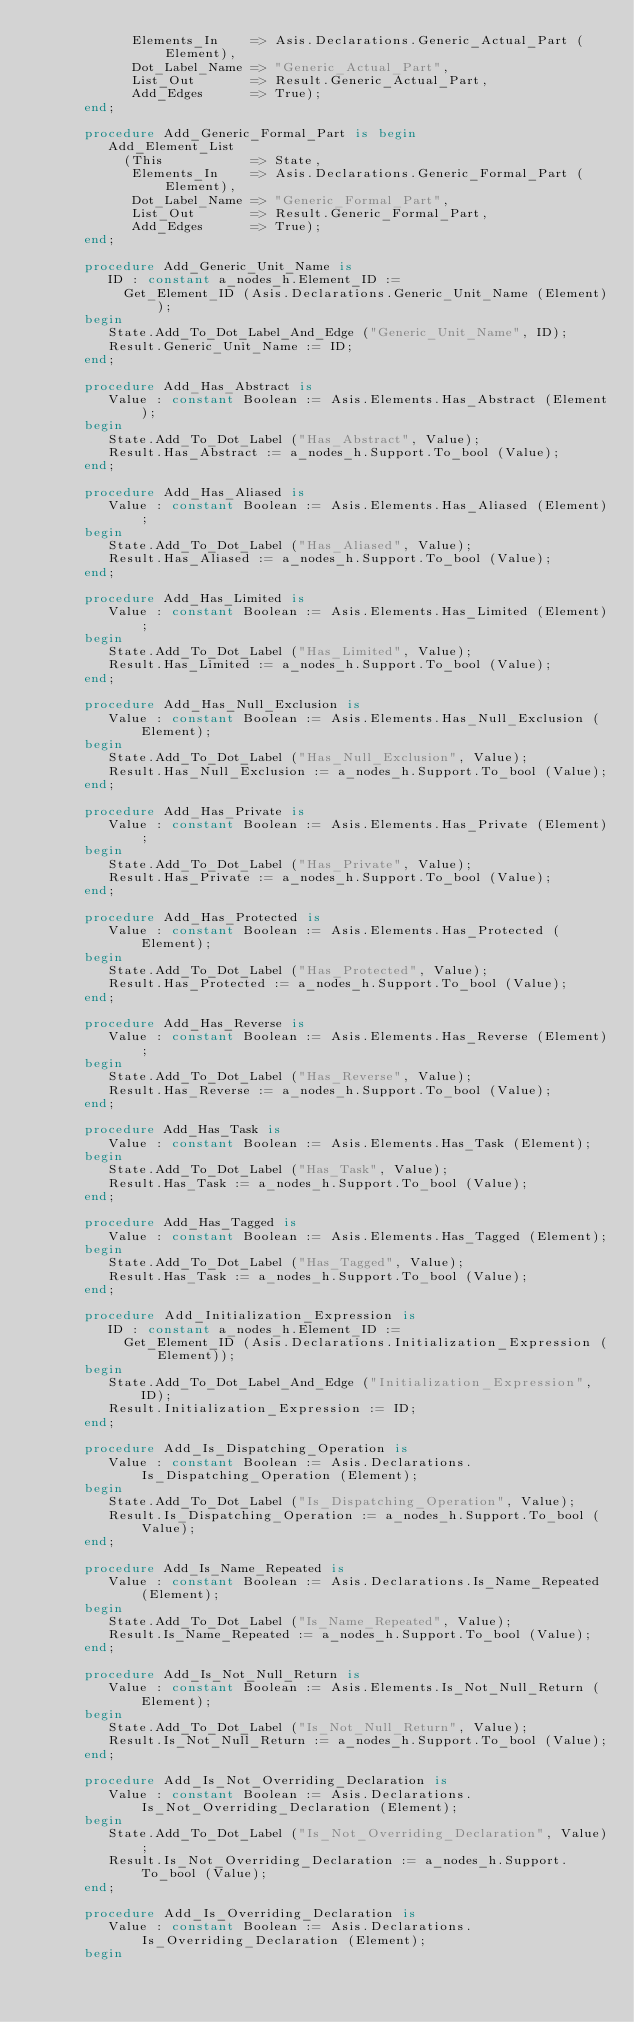Convert code to text. <code><loc_0><loc_0><loc_500><loc_500><_Ada_>            Elements_In    => Asis.Declarations.Generic_Actual_Part (Element),
            Dot_Label_Name => "Generic_Actual_Part",
            List_Out       => Result.Generic_Actual_Part,
            Add_Edges      => True);
      end;

      procedure Add_Generic_Formal_Part is begin
         Add_Element_List
           (This           => State,
            Elements_In    => Asis.Declarations.Generic_Formal_Part (Element),
            Dot_Label_Name => "Generic_Formal_Part",
            List_Out       => Result.Generic_Formal_Part,
            Add_Edges      => True);
      end;

      procedure Add_Generic_Unit_Name is
         ID : constant a_nodes_h.Element_ID :=
           Get_Element_ID (Asis.Declarations.Generic_Unit_Name (Element));
      begin
         State.Add_To_Dot_Label_And_Edge ("Generic_Unit_Name", ID);
         Result.Generic_Unit_Name := ID;
      end;

      procedure Add_Has_Abstract is
         Value : constant Boolean := Asis.Elements.Has_Abstract (Element);
      begin
         State.Add_To_Dot_Label ("Has_Abstract", Value);
         Result.Has_Abstract := a_nodes_h.Support.To_bool (Value);
      end;

      procedure Add_Has_Aliased is
         Value : constant Boolean := Asis.Elements.Has_Aliased (Element);
      begin
         State.Add_To_Dot_Label ("Has_Aliased", Value);
         Result.Has_Aliased := a_nodes_h.Support.To_bool (Value);
      end;

      procedure Add_Has_Limited is
         Value : constant Boolean := Asis.Elements.Has_Limited (Element);
      begin
         State.Add_To_Dot_Label ("Has_Limited", Value);
         Result.Has_Limited := a_nodes_h.Support.To_bool (Value);
      end;

      procedure Add_Has_Null_Exclusion is
         Value : constant Boolean := Asis.Elements.Has_Null_Exclusion (Element);
      begin
         State.Add_To_Dot_Label ("Has_Null_Exclusion", Value);
         Result.Has_Null_Exclusion := a_nodes_h.Support.To_bool (Value);
      end;

      procedure Add_Has_Private is
         Value : constant Boolean := Asis.Elements.Has_Private (Element);
      begin
         State.Add_To_Dot_Label ("Has_Private", Value);
         Result.Has_Private := a_nodes_h.Support.To_bool (Value);
      end;

      procedure Add_Has_Protected is
         Value : constant Boolean := Asis.Elements.Has_Protected (Element);
      begin
         State.Add_To_Dot_Label ("Has_Protected", Value);
         Result.Has_Protected := a_nodes_h.Support.To_bool (Value);
      end;

      procedure Add_Has_Reverse is
         Value : constant Boolean := Asis.Elements.Has_Reverse (Element);
      begin
         State.Add_To_Dot_Label ("Has_Reverse", Value);
         Result.Has_Reverse := a_nodes_h.Support.To_bool (Value);
      end;

      procedure Add_Has_Task is
         Value : constant Boolean := Asis.Elements.Has_Task (Element);
      begin
         State.Add_To_Dot_Label ("Has_Task", Value);
         Result.Has_Task := a_nodes_h.Support.To_bool (Value);
      end;

      procedure Add_Has_Tagged is
         Value : constant Boolean := Asis.Elements.Has_Tagged (Element);
      begin
         State.Add_To_Dot_Label ("Has_Tagged", Value);
         Result.Has_Task := a_nodes_h.Support.To_bool (Value);
      end;

      procedure Add_Initialization_Expression is
         ID : constant a_nodes_h.Element_ID :=
           Get_Element_ID (Asis.Declarations.Initialization_Expression (Element));
      begin
         State.Add_To_Dot_Label_And_Edge ("Initialization_Expression", ID);
         Result.Initialization_Expression := ID;
      end;

      procedure Add_Is_Dispatching_Operation is
         Value : constant Boolean := Asis.Declarations.Is_Dispatching_Operation (Element);
      begin
         State.Add_To_Dot_Label ("Is_Dispatching_Operation", Value);
         Result.Is_Dispatching_Operation := a_nodes_h.Support.To_bool (Value);
      end;

      procedure Add_Is_Name_Repeated is
         Value : constant Boolean := Asis.Declarations.Is_Name_Repeated (Element);
      begin
         State.Add_To_Dot_Label ("Is_Name_Repeated", Value);
         Result.Is_Name_Repeated := a_nodes_h.Support.To_bool (Value);
      end;

      procedure Add_Is_Not_Null_Return is
         Value : constant Boolean := Asis.Elements.Is_Not_Null_Return (Element);
      begin
         State.Add_To_Dot_Label ("Is_Not_Null_Return", Value);
         Result.Is_Not_Null_Return := a_nodes_h.Support.To_bool (Value);
      end;

      procedure Add_Is_Not_Overriding_Declaration is
         Value : constant Boolean := Asis.Declarations.Is_Not_Overriding_Declaration (Element);
      begin
         State.Add_To_Dot_Label ("Is_Not_Overriding_Declaration", Value);
         Result.Is_Not_Overriding_Declaration := a_nodes_h.Support.To_bool (Value);
      end;

      procedure Add_Is_Overriding_Declaration is
         Value : constant Boolean := Asis.Declarations.Is_Overriding_Declaration (Element);
      begin</code> 